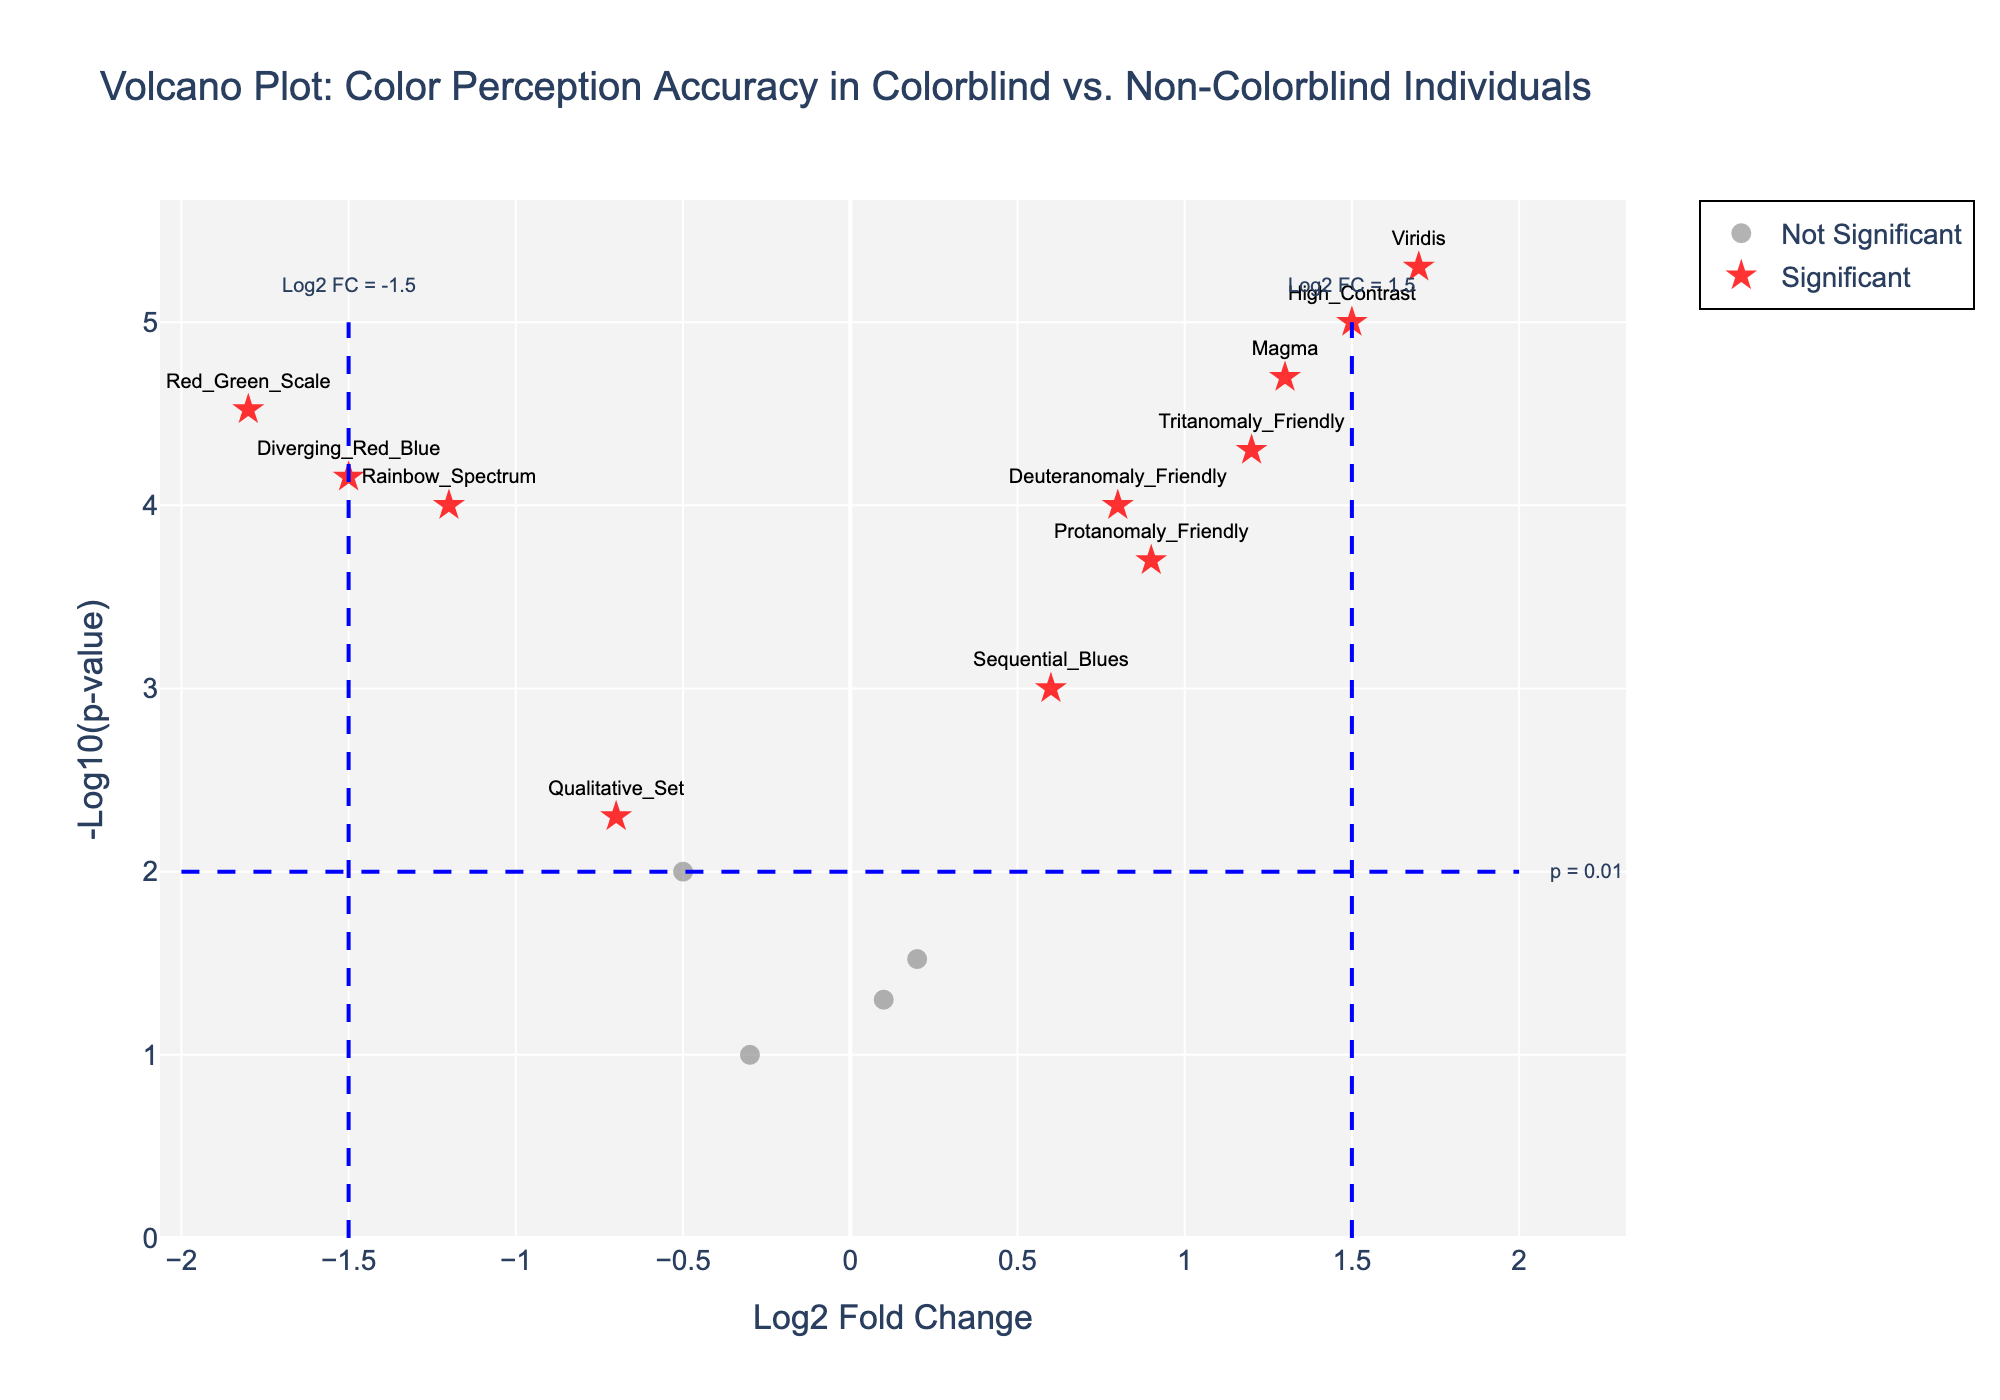How many color palettes are identified as significant? To find out how many color palettes are identified as significant, look for points marked with red stars. Each red star represents a significant color palette.
Answer: 10 Which color palette has the highest log2 fold change? Locate the point on the x-axis with the highest positive value for log2 fold change. The label next to this point indicates the corresponding color palette.
Answer: Viridis Which color palette has the lowest p-value? To find the color palette with the lowest p-value, locate the point with the highest value on the y-axis (-Log10(p-value)). The label next to this point indicates the corresponding color palette.
Answer: Viridis What is the log2 fold change threshold for significance according to the plot? Identify the lines or annotations that indicate the significance threshold for log2 fold change. These lines are usually drawn vertically and annotated.
Answer: ±1.5 How many non-significant color palettes are shown in the plot? Count the number of points marked as non-significant (gray circles). These represent the non-significant color palettes.
Answer: 5 Which significant color palette is closest to the zero log2 fold change? Identify the significant points (red stars) closest to the zero position on the x-axis (log2 fold change). The label next to this point indicates the color palette.
Answer: Sequential_Blues What does a higher value on the y-axis in this plot represent? In a volcano plot, the y-axis represents -Log10(p-value), so a higher value means a smaller p-value, indicating higher statistical significance.
Answer: Smaller p-value How many color palettes have a log2 fold change less than -1.5? Count the number of points to the left of the vertical line at -1.5 log2 fold change. These points should also be labeled to indicate their respective color palettes.
Answer: 2 Which color palette has a low log2 fold change but is still significant? Identify significant points (red stars) that have low log2 fold change values (near zero but not zero). The label next to these points indicates their color palettes.
Answer: Sequential_Blues Is there any color palette in the gray circles below the p = 0.01 line? Examine the non-significant points (gray circles) and see if any are located below the horizontal line that represents the p = 0.01 threshold.
Answer: No 